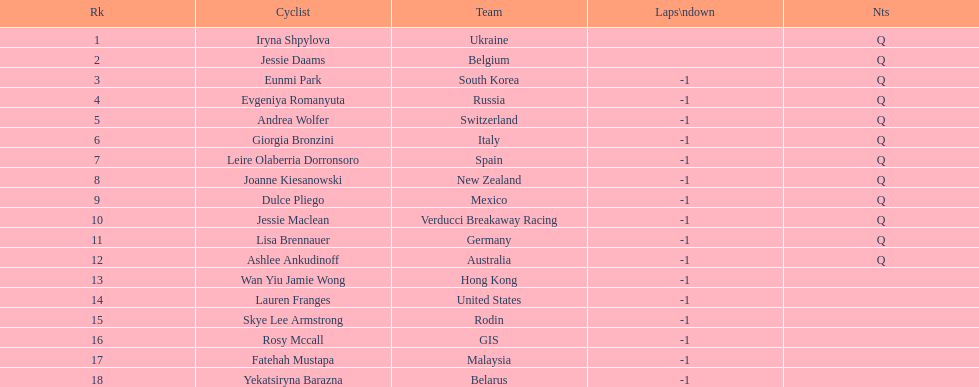Who is the most recent cyclist named? Yekatsiryna Barazna. 